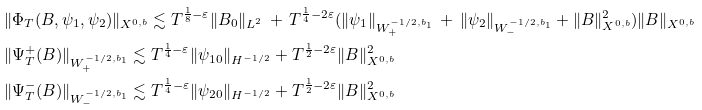<formula> <loc_0><loc_0><loc_500><loc_500>& \| \Phi _ { T } ( B , \psi _ { 1 } , \psi _ { 2 } ) \| _ { X ^ { 0 , b } } \lesssim T ^ { \frac { 1 } { 8 } - \varepsilon } \| B _ { 0 } \| _ { L ^ { 2 } } \, + \, T ^ { \frac { 1 } { 4 } - 2 \varepsilon } ( \| \psi _ { 1 } \| _ { W _ { + } ^ { - 1 / 2 , b _ { 1 } } } \, + \, \| \psi _ { 2 } \| _ { W _ { - } ^ { - 1 / 2 , b _ { 1 } } } + \| B \| _ { X ^ { 0 , b } } ^ { 2 } ) \| B \| _ { X ^ { 0 , b } } \\ & \| \Psi _ { T } ^ { + } ( B ) \| _ { W _ { + } ^ { - 1 / 2 , b _ { 1 } } } \lesssim T ^ { \frac { 1 } { 4 } - \varepsilon } \| \psi _ { 1 0 } \| _ { H ^ { - 1 / 2 } } + T ^ { \frac { 1 } { 2 } - 2 \varepsilon } \| B \| _ { X ^ { 0 , b } } ^ { 2 } \\ & \| \Psi _ { T } ^ { - } ( B ) \| _ { W _ { - } ^ { - 1 / 2 , b _ { 1 } } } \lesssim T ^ { \frac { 1 } { 4 } - \varepsilon } \| \psi _ { 2 0 } \| _ { H ^ { - 1 / 2 } } + T ^ { \frac { 1 } { 2 } - 2 \varepsilon } \| B \| _ { X ^ { 0 , b } } ^ { 2 }</formula> 